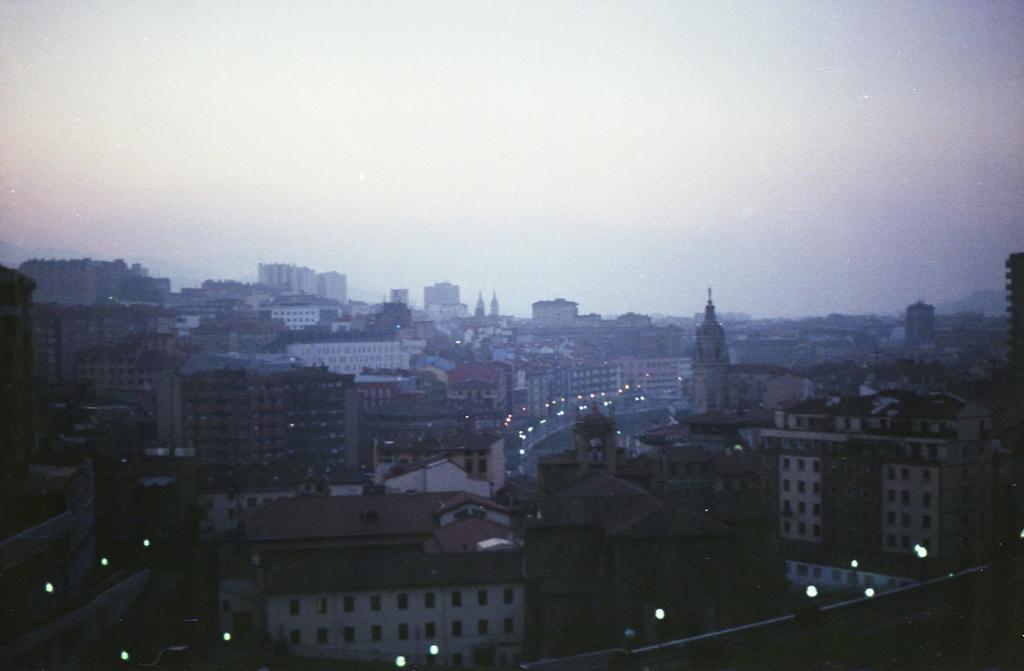Please provide a concise description of this image. In this image at the bottom there are few buildings, there are some lights visible, at the top there is the sky. 